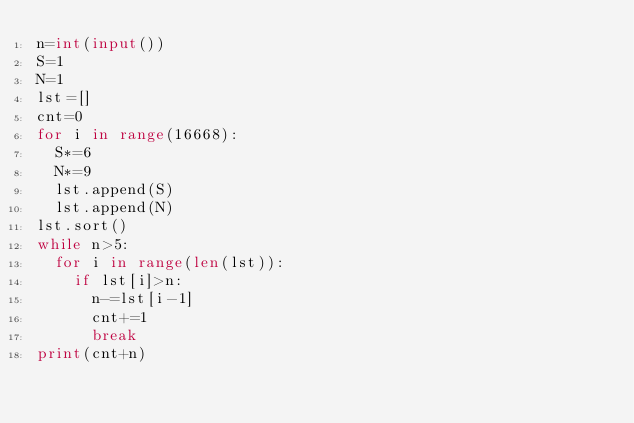<code> <loc_0><loc_0><loc_500><loc_500><_Python_>n=int(input())
S=1
N=1
lst=[]
cnt=0
for i in range(16668):
  S*=6
  N*=9
  lst.append(S)
  lst.append(N)
lst.sort()
while n>5:
  for i in range(len(lst)):
    if lst[i]>n:
      n-=lst[i-1]
      cnt+=1
      break
print(cnt+n)
</code> 